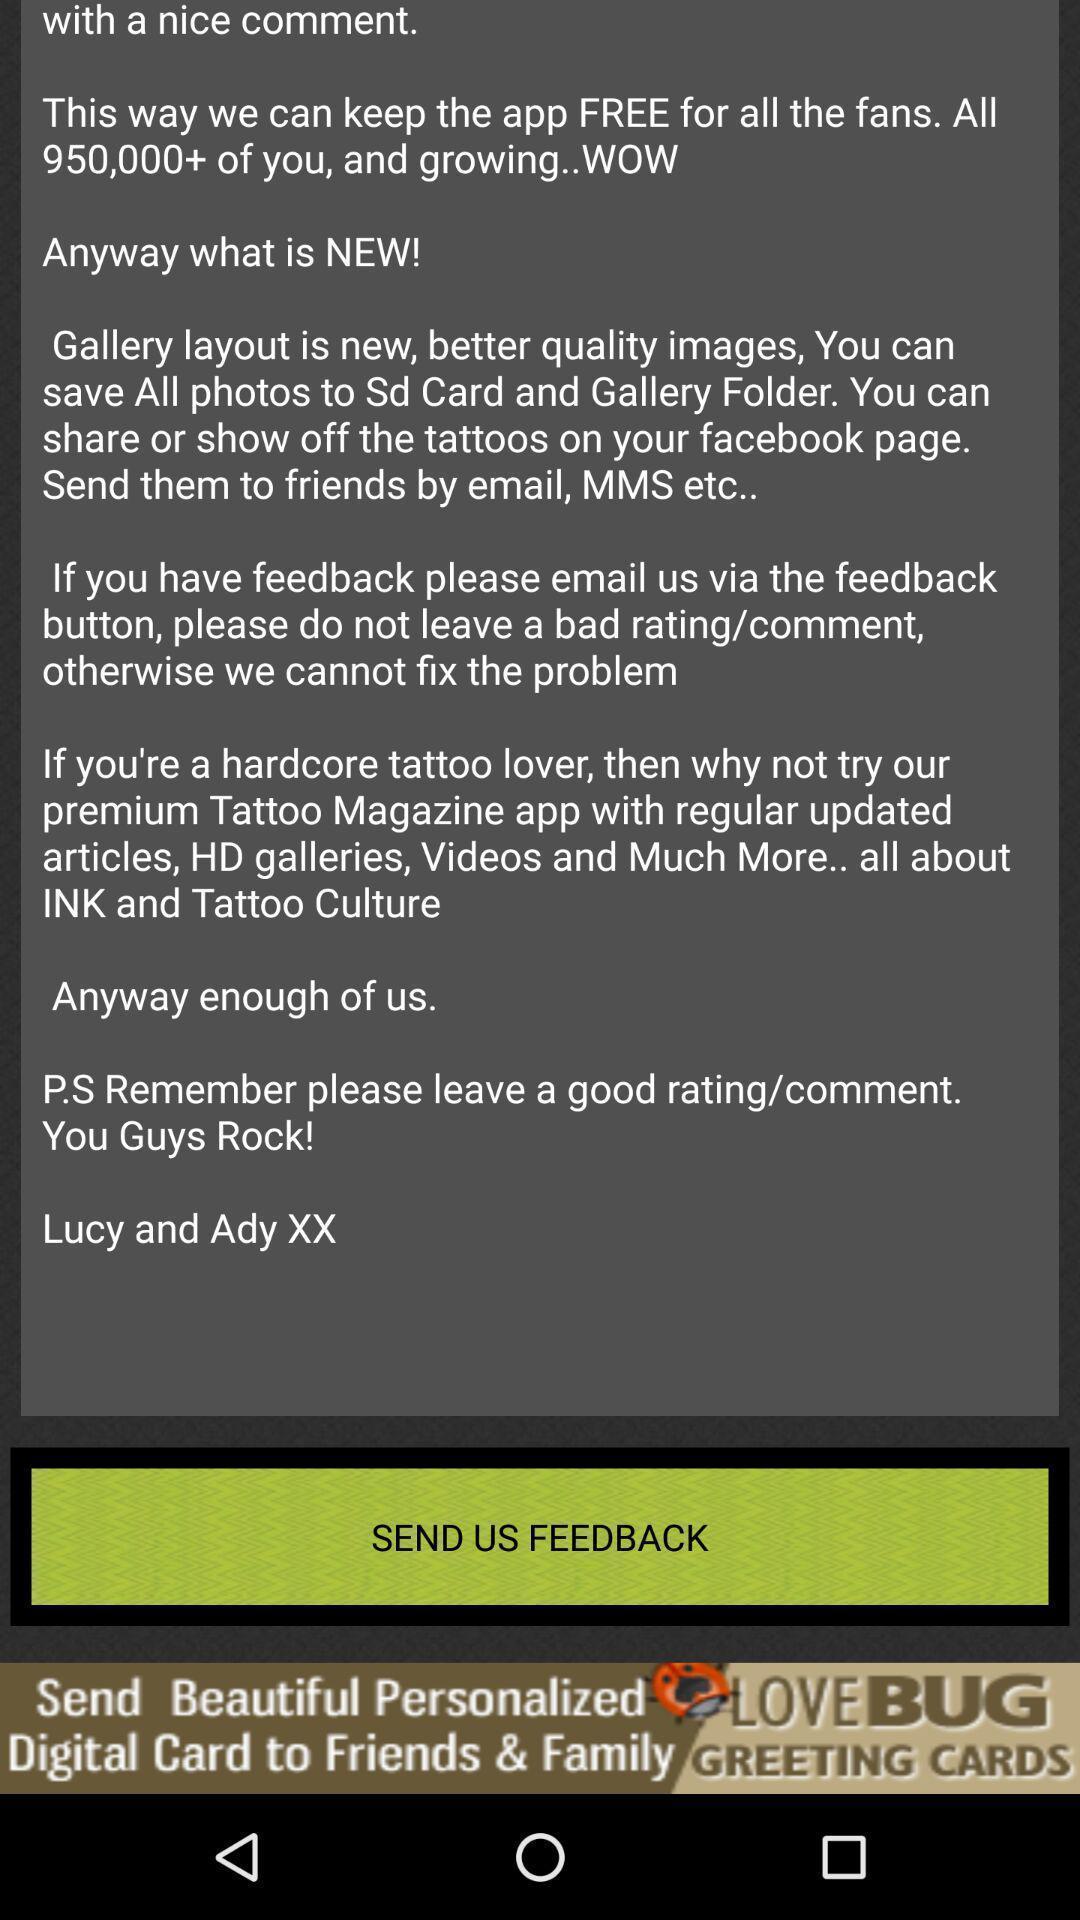Please provide a description for this image. Pop-up asking to send feedback. 